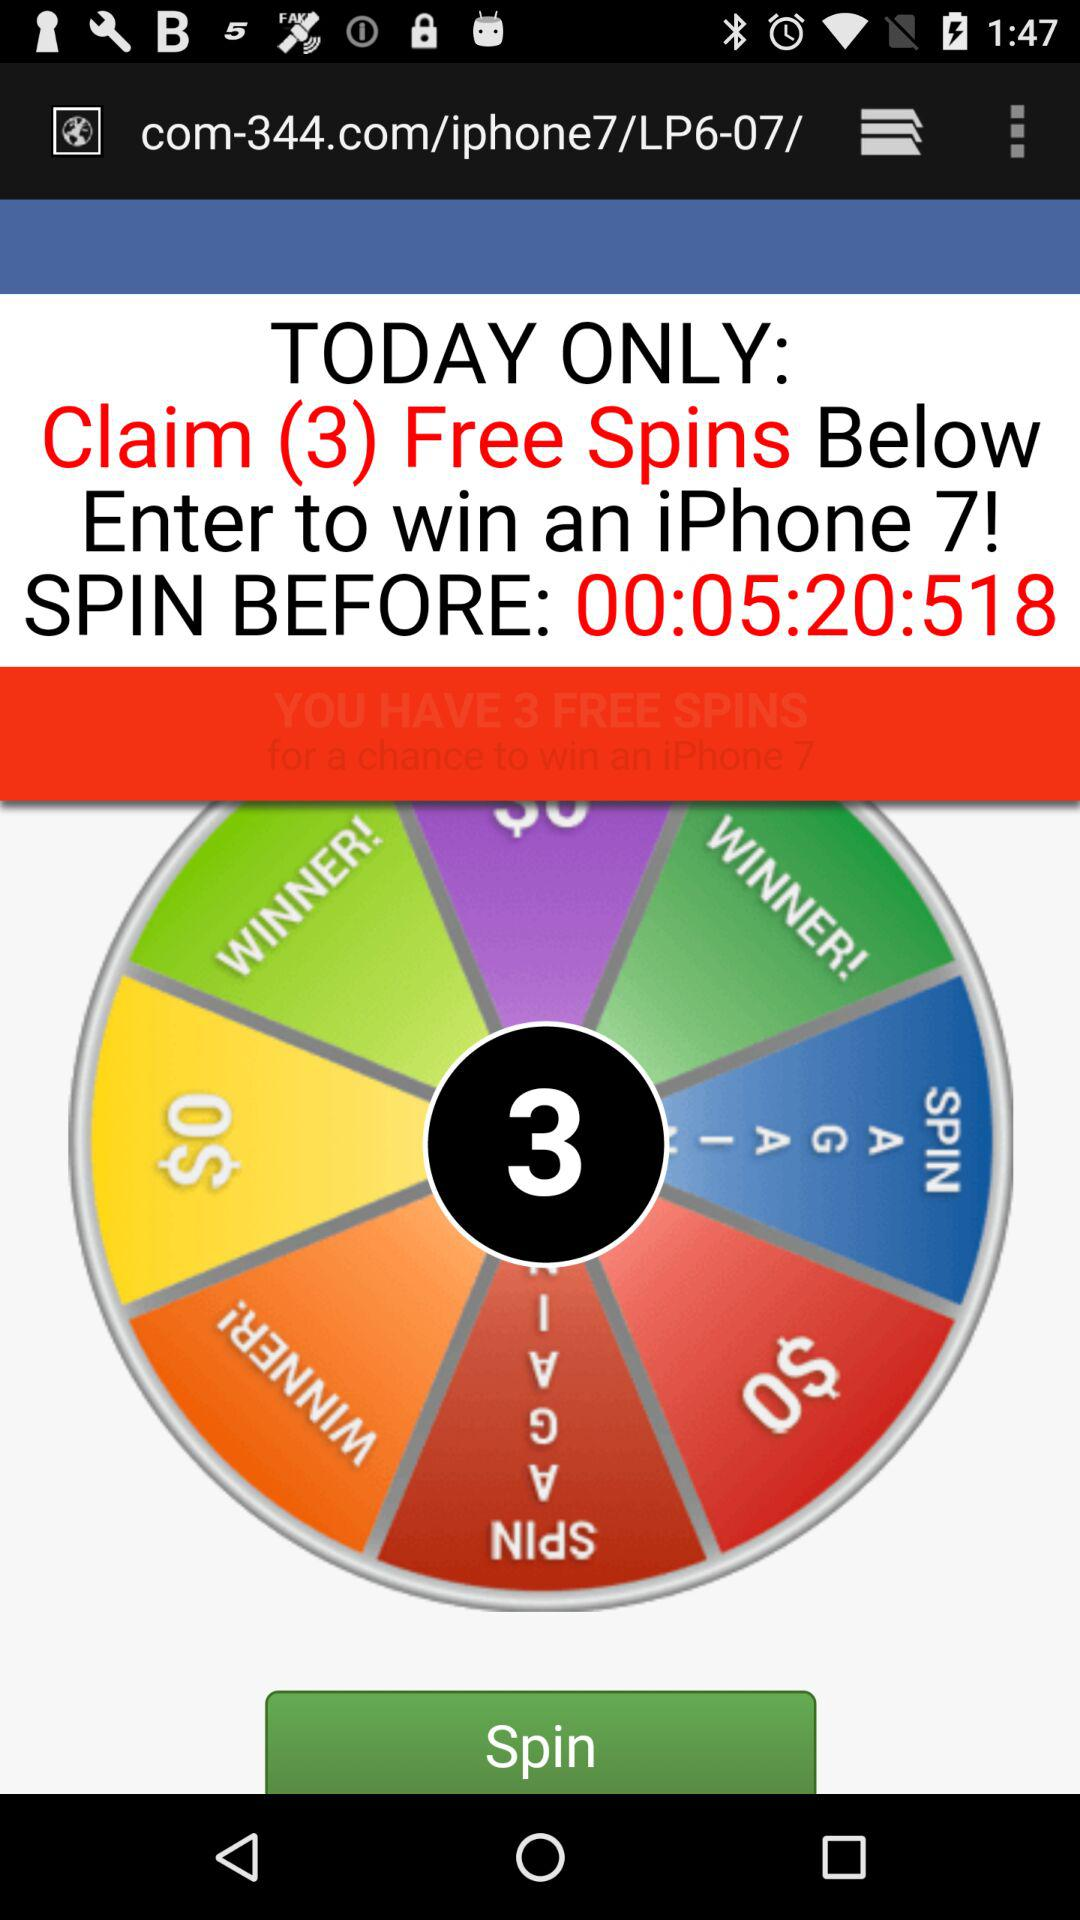What is the number of free spins? The number of free spins is 3. 